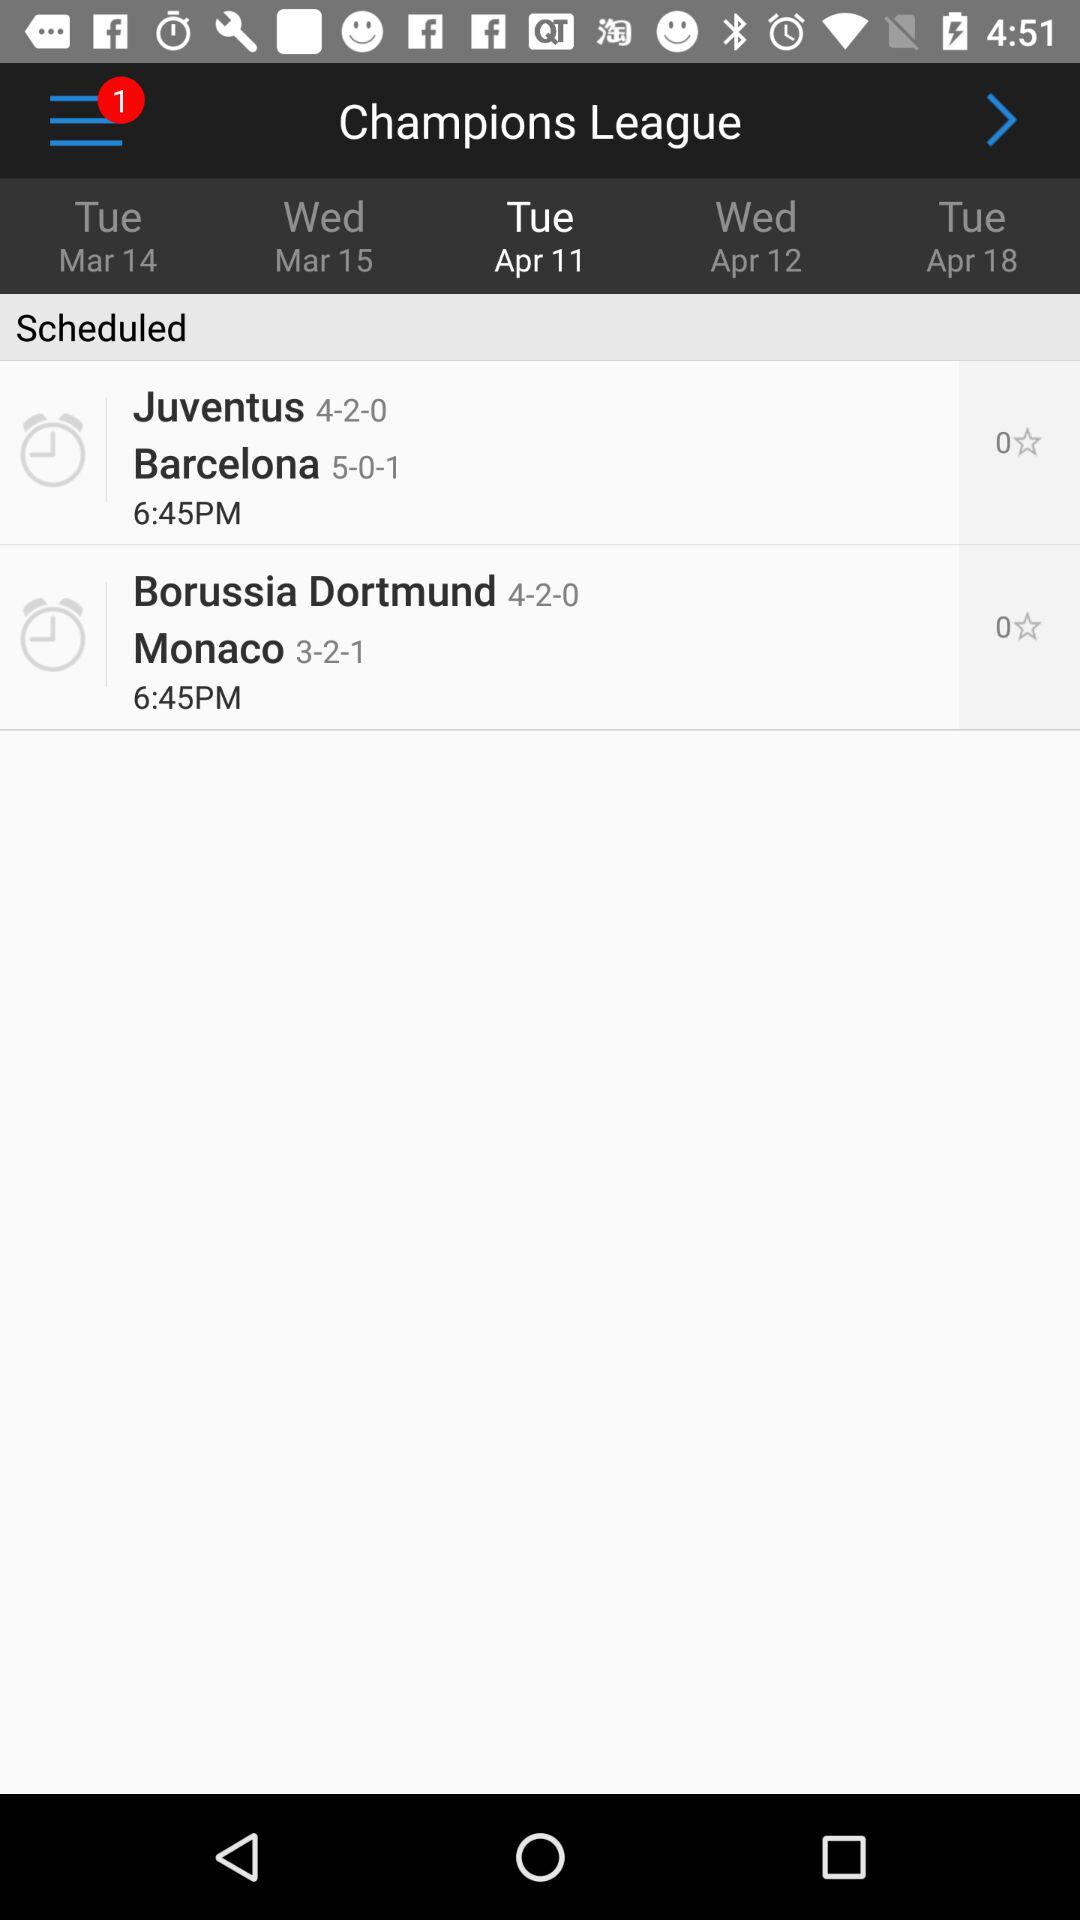When was the Juventus vs. Barcelona match scheduled? The Juventus vs. Barcelona match was scheduled for 6:45 PM. 